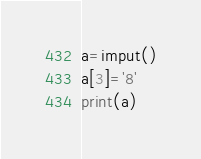<code> <loc_0><loc_0><loc_500><loc_500><_Python_>a=imput()
a[3]='8'
print(a)</code> 